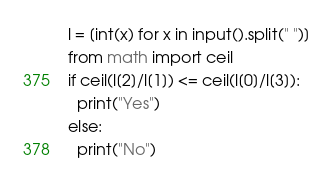<code> <loc_0><loc_0><loc_500><loc_500><_Python_>l = [int(x) for x in input().split(" ")]
from math import ceil
if ceil(l[2]/l[1]) <= ceil(l[0]/l[3]):
  print("Yes")
else:
  print("No")</code> 